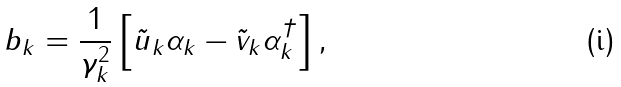Convert formula to latex. <formula><loc_0><loc_0><loc_500><loc_500>b _ { k } = \frac { 1 } { \gamma _ { k } ^ { 2 } } \left [ \tilde { u } _ { k } \alpha _ { k } - \tilde { v } _ { k } \alpha _ { k } ^ { \dagger } \right ] ,</formula> 